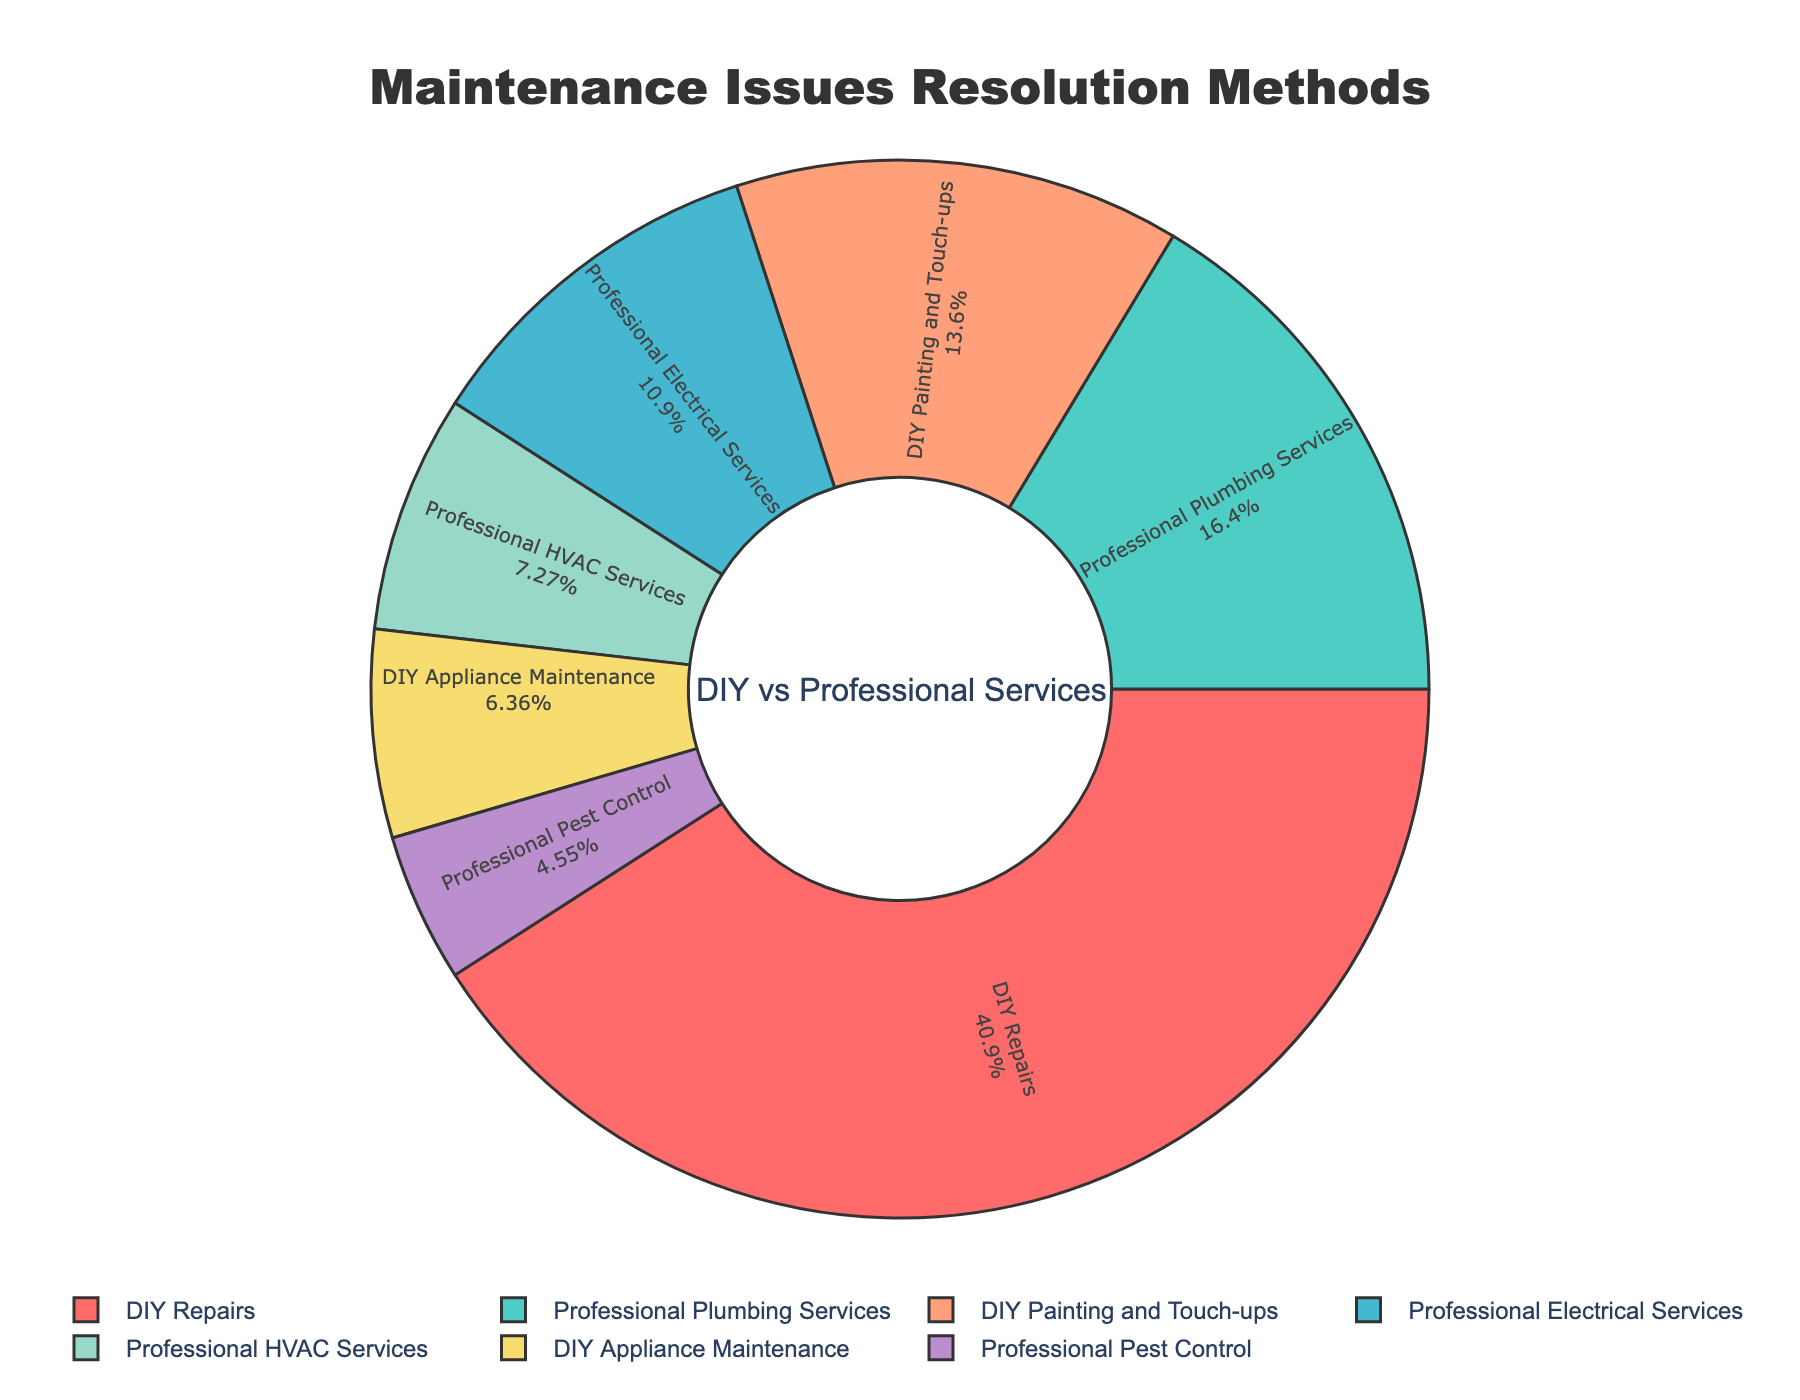What is the total percentage of maintenance issues resolved using professional services? To find the total percentage of maintenance issues resolved using professional services, sum the percentages of “Professional Plumbing Services” (18%), “Professional Electrical Services” (12%), “Professional HVAC Services” (8%), and “Professional Pest Control” (5%). So, 18 + 12 + 8 + 5 = 43%
Answer: 43% Which maintenance type has the highest percentage of issues resolved using DIY methods? Compare the percentages of maintenance issues resolved using DIY methods: “DIY Repairs” (45%), “DIY Painting and Touch-ups” (15%), “DIY Appliance Maintenance” (7%). The highest percentage is “DIY Repairs” at 45%
Answer: DIY Repairs How does the percentage of DIY repairs compare to the percentage of professional plumbing services? Compare the values for "DIY Repairs" (45%) and "Professional Plumbing Services" (18%) directly. 45% is greater than 18%
Answer: DIY Repairs has a higher percentage What is the combined percentage of DIY Painting and Touch-ups and Professional HVAC Services? Add the percentages of “DIY Painting and Touch-ups” (15%) and “Professional HVAC Services” (8%) together. So, 15 + 8 = 23%
Answer: 23% Which color represents the largest segment in the pie chart? The largest segment is “DIY Repairs” with 45%, represented by the red color in the pie chart
Answer: Red Is the share of Professional Electrical Services more or less than the share of DIY Painting and Touch-ups? Compare the percentages of “Professional Electrical Services” (12%) and “DIY Painting and Touch-ups” (15%). 12% is less than 15%
Answer: Less What is the difference in percentage between DIY repairs and Professional Electrical Services? Subtract the percentage of “Professional Electrical Services” (12%) from the percentage of “DIY Repairs” (45%). So, 45 - 12 = 33%
Answer: 33% What are the combined percentages of DIY methods excluding DIY Repairs? Add the percentages of “DIY Painting and Touch-ups” (15%) and “DIY Appliance Maintenance” (7%). So, 15 + 7 = 22%
Answer: 22% How many percentage points higher is the combined percentage of all DIY methods compared to Professional Plumbing Services alone? First, calculate the total percentage for all DIY methods: “DIY Repairs” (45%), “DIY Painting and Touch-ups” (15%), and “DIY Appliance Maintenance” (7%). So, 45 + 15 + 7 = 67%. Then, subtract the percentage of “Professional Plumbing Services” (18%) from 67%. So, 67 - 18 = 49 percentage points
Answer: 49 percentage points 